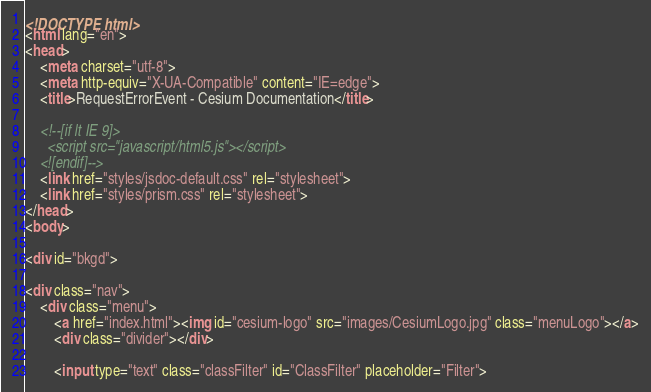Convert code to text. <code><loc_0><loc_0><loc_500><loc_500><_HTML_><!DOCTYPE html>
<html lang="en">
<head>
    <meta charset="utf-8">
    <meta http-equiv="X-UA-Compatible" content="IE=edge">
    <title>RequestErrorEvent - Cesium Documentation</title>

    <!--[if lt IE 9]>
      <script src="javascript/html5.js"></script>
    <![endif]-->
    <link href="styles/jsdoc-default.css" rel="stylesheet">
    <link href="styles/prism.css" rel="stylesheet">
</head>
<body>

<div id="bkgd">

<div class="nav">
    <div class="menu">
        <a href="index.html"><img id="cesium-logo" src="images/CesiumLogo.jpg" class="menuLogo"></a>
        <div class="divider"></div>

        <input type="text" class="classFilter" id="ClassFilter" placeholder="Filter">
</code> 